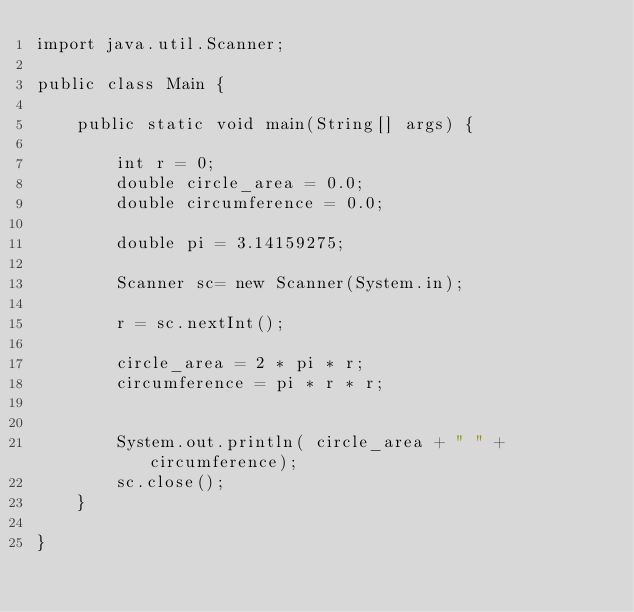<code> <loc_0><loc_0><loc_500><loc_500><_Java_>import java.util.Scanner;

public class Main {

    public static void main(String[] args) {

        int r = 0;
        double circle_area = 0.0;
        double circumference = 0.0;

        double pi = 3.14159275;

        Scanner sc= new Scanner(System.in);

        r = sc.nextInt();

        circle_area = 2 * pi * r;
        circumference = pi * r * r;


        System.out.println( circle_area + " " + circumference);
        sc.close();
    }

}

</code> 